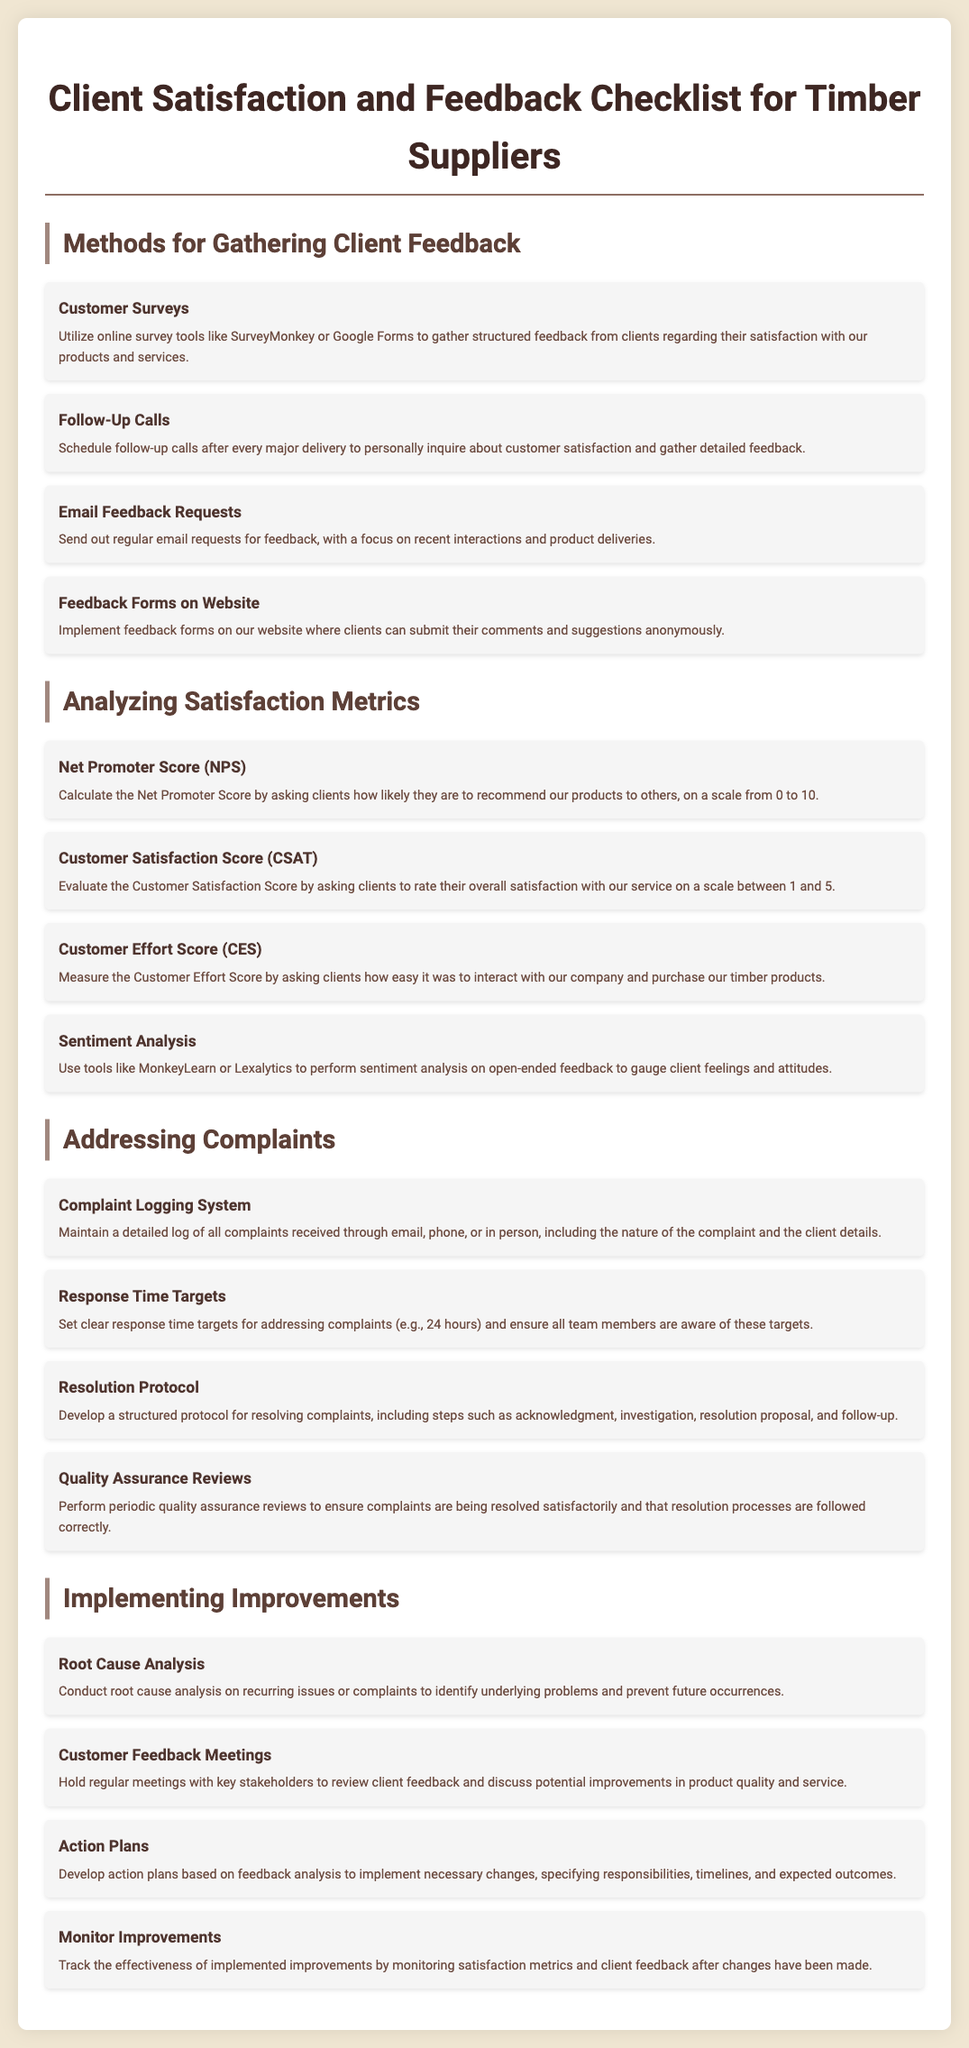what is one method for gathering client feedback? The document lists several methods for gathering client feedback, one of which is Customer Surveys.
Answer: Customer Surveys what is the maximum score for the Net Promoter Score (NPS)? The document states that the NPS is calculated on a scale from 0 to 10.
Answer: 10 how many satisfaction metrics are mentioned in the document? The document lists four satisfaction metrics under the "Analyzing Satisfaction Metrics" section.
Answer: 4 what is the first step in the Resolution Protocol? The document outlines the Resolution Protocol, stating that the first step is acknowledgment.
Answer: acknowledgment which analysis method is suggested for recurring issues? The document recommends conducting Root Cause Analysis for recurring issues.
Answer: Root Cause Analysis what tool can be used for sentiment analysis? The document mentions using tools like MonkeyLearn or Lexalytics for sentiment analysis.
Answer: MonkeyLearn or Lexalytics what should be tracked to monitor improvements? The document suggests monitoring satisfaction metrics and client feedback to track improvements.
Answer: satisfaction metrics and client feedback how often should Customer Feedback Meetings be held? The document does not specify the frequency of these meetings, indicating they should be regular.
Answer: regular what response time target is set for addressing complaints? The document specifies a clear response time target of 24 hours for addressing complaints.
Answer: 24 hours 